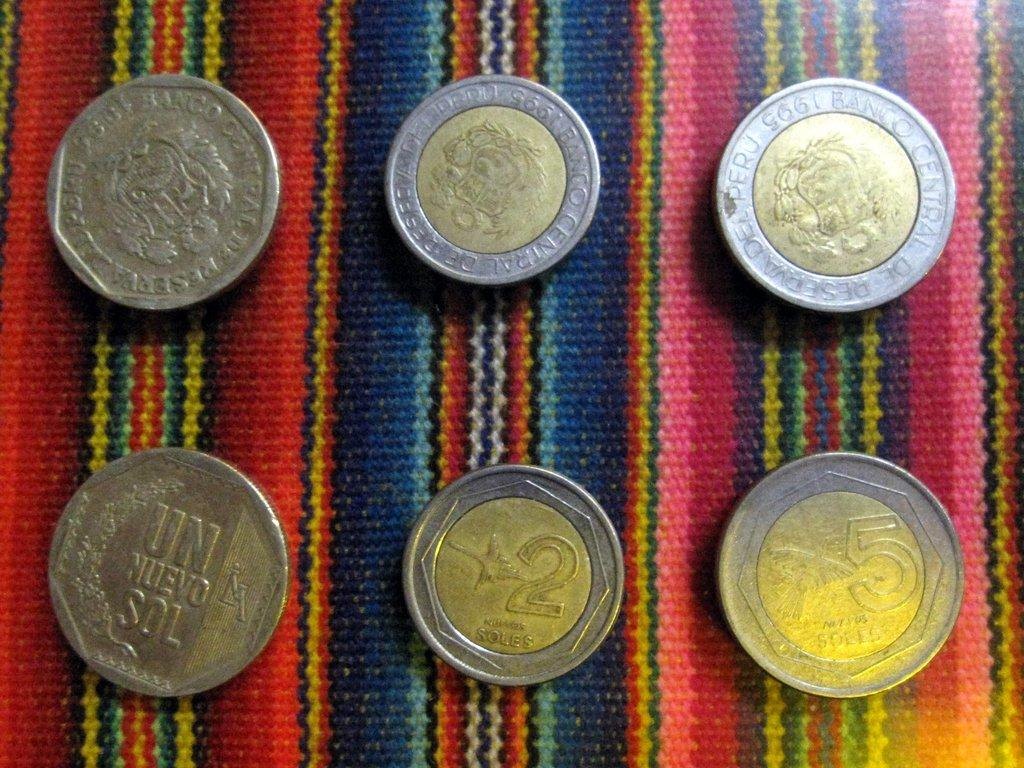<image>
Render a clear and concise summary of the photo. several Soles coins like 2 and 5 on a colorful surface 